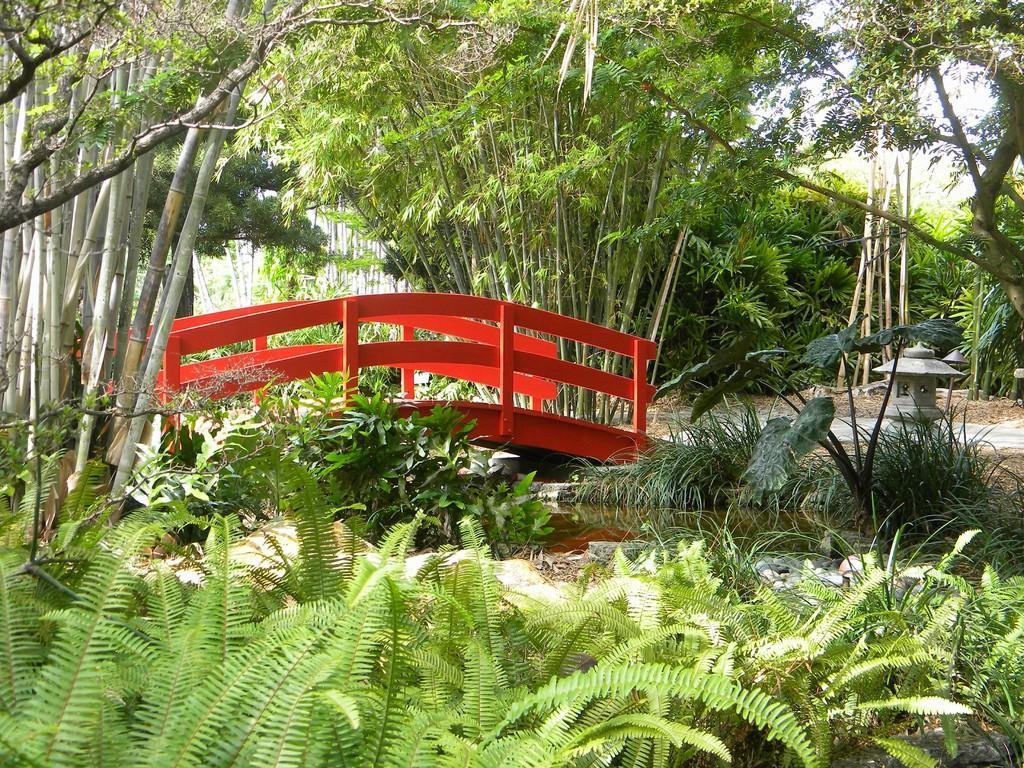How would you summarize this image in a sentence or two? In this image we can see a walkway bridge, shrubs, plants, water, trees, bushes and sky. 